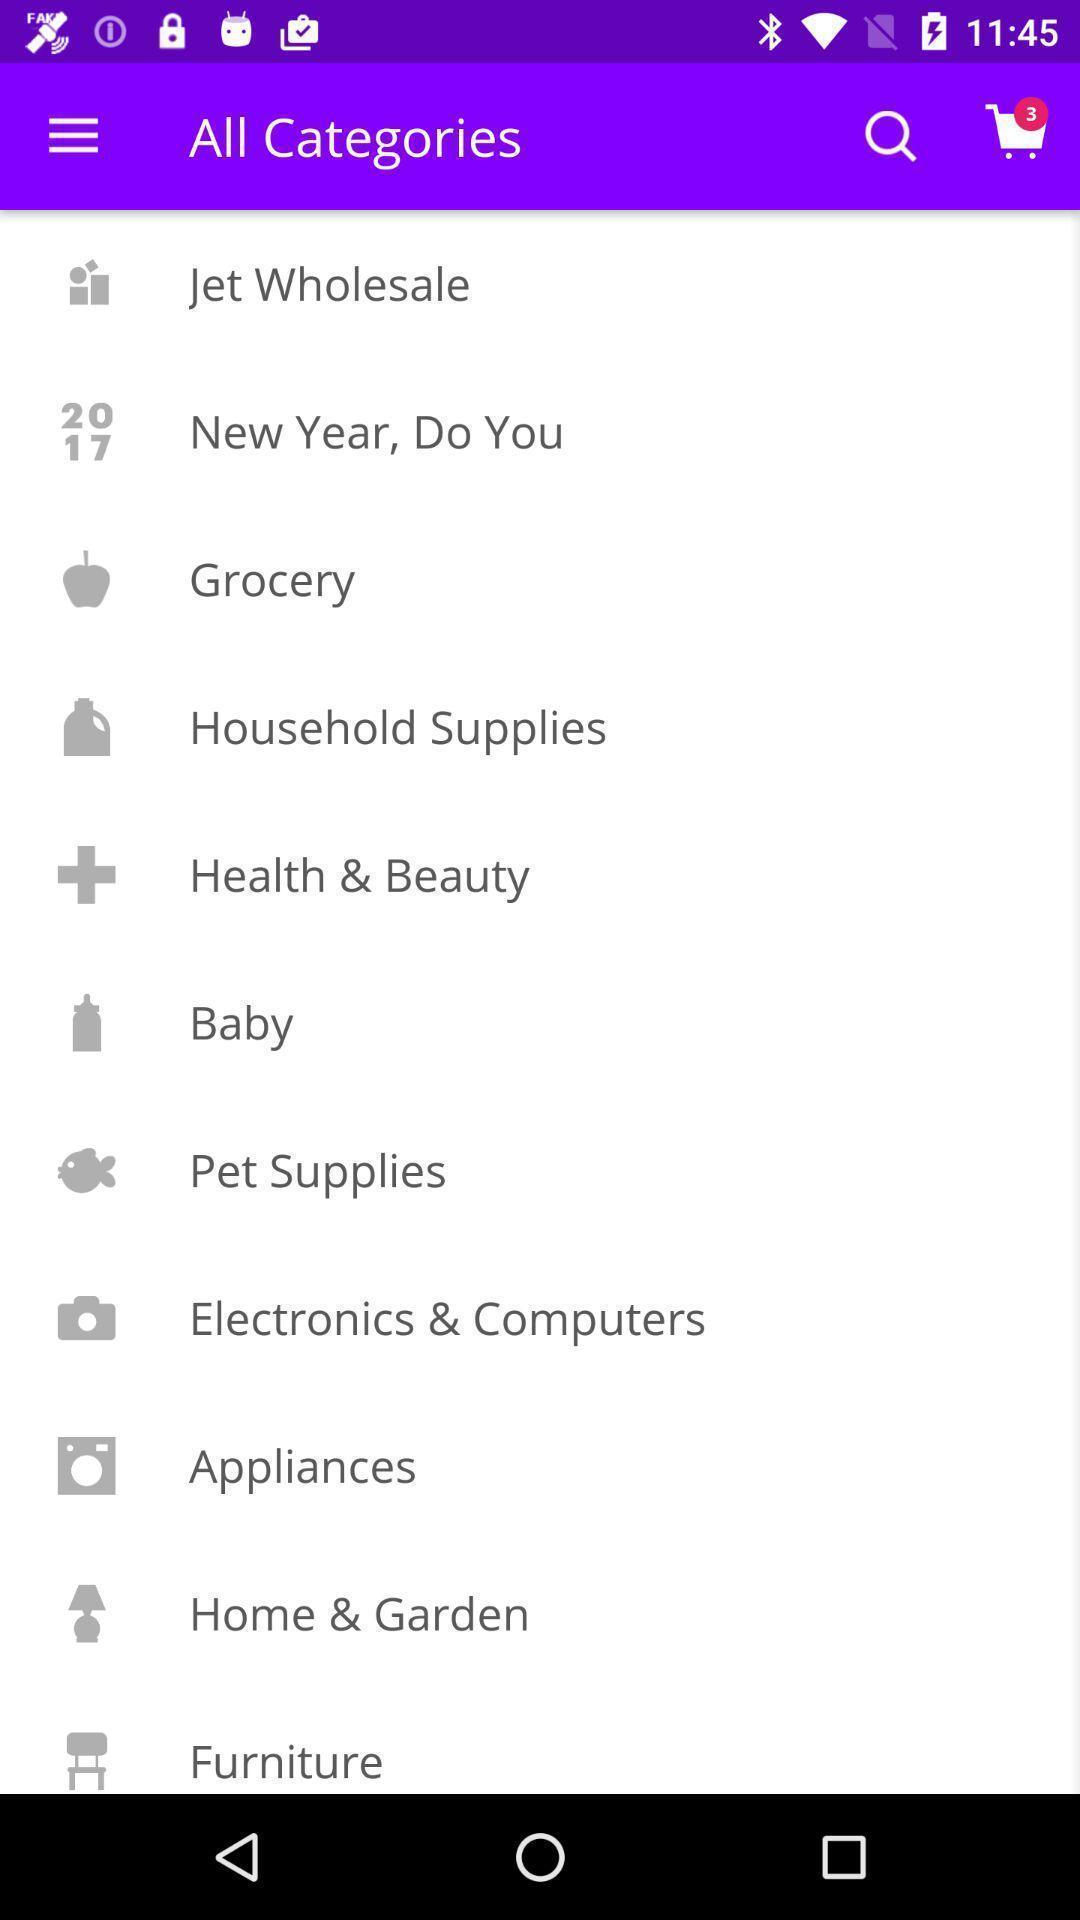What is the overall content of this screenshot? Screen showing list of various categories. 